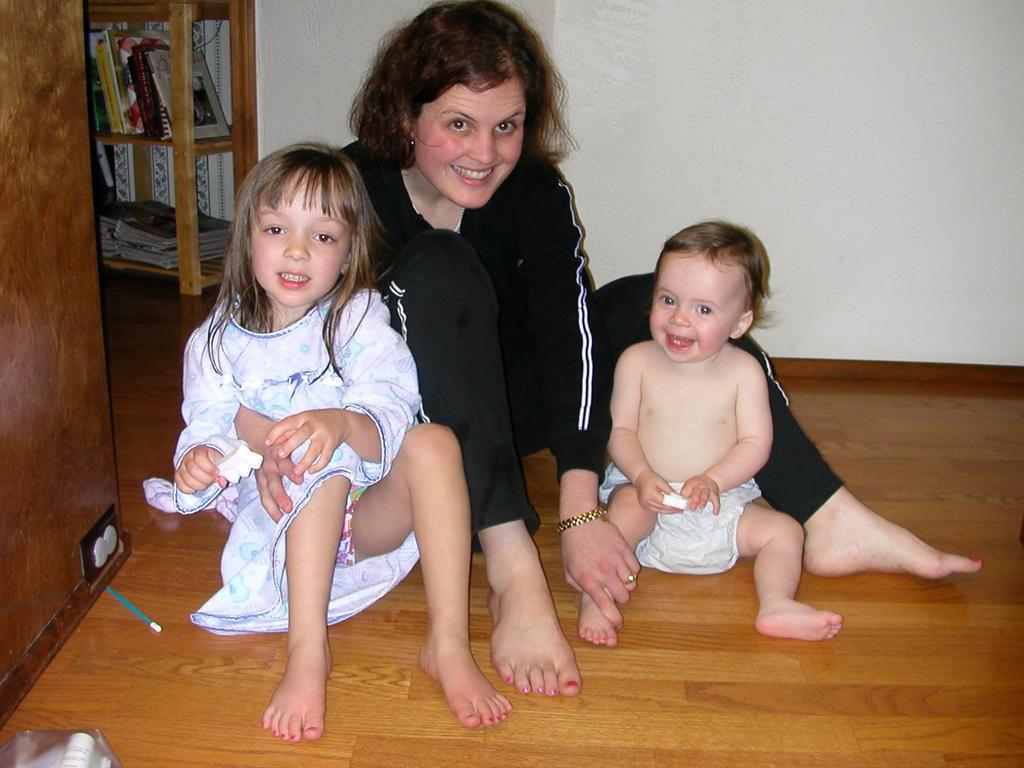Describe this image in one or two sentences. In this image I can see few people and the baby is sitting on the brown color floor. I can see few books in the wooden rack. I can see the wall and few objects. 